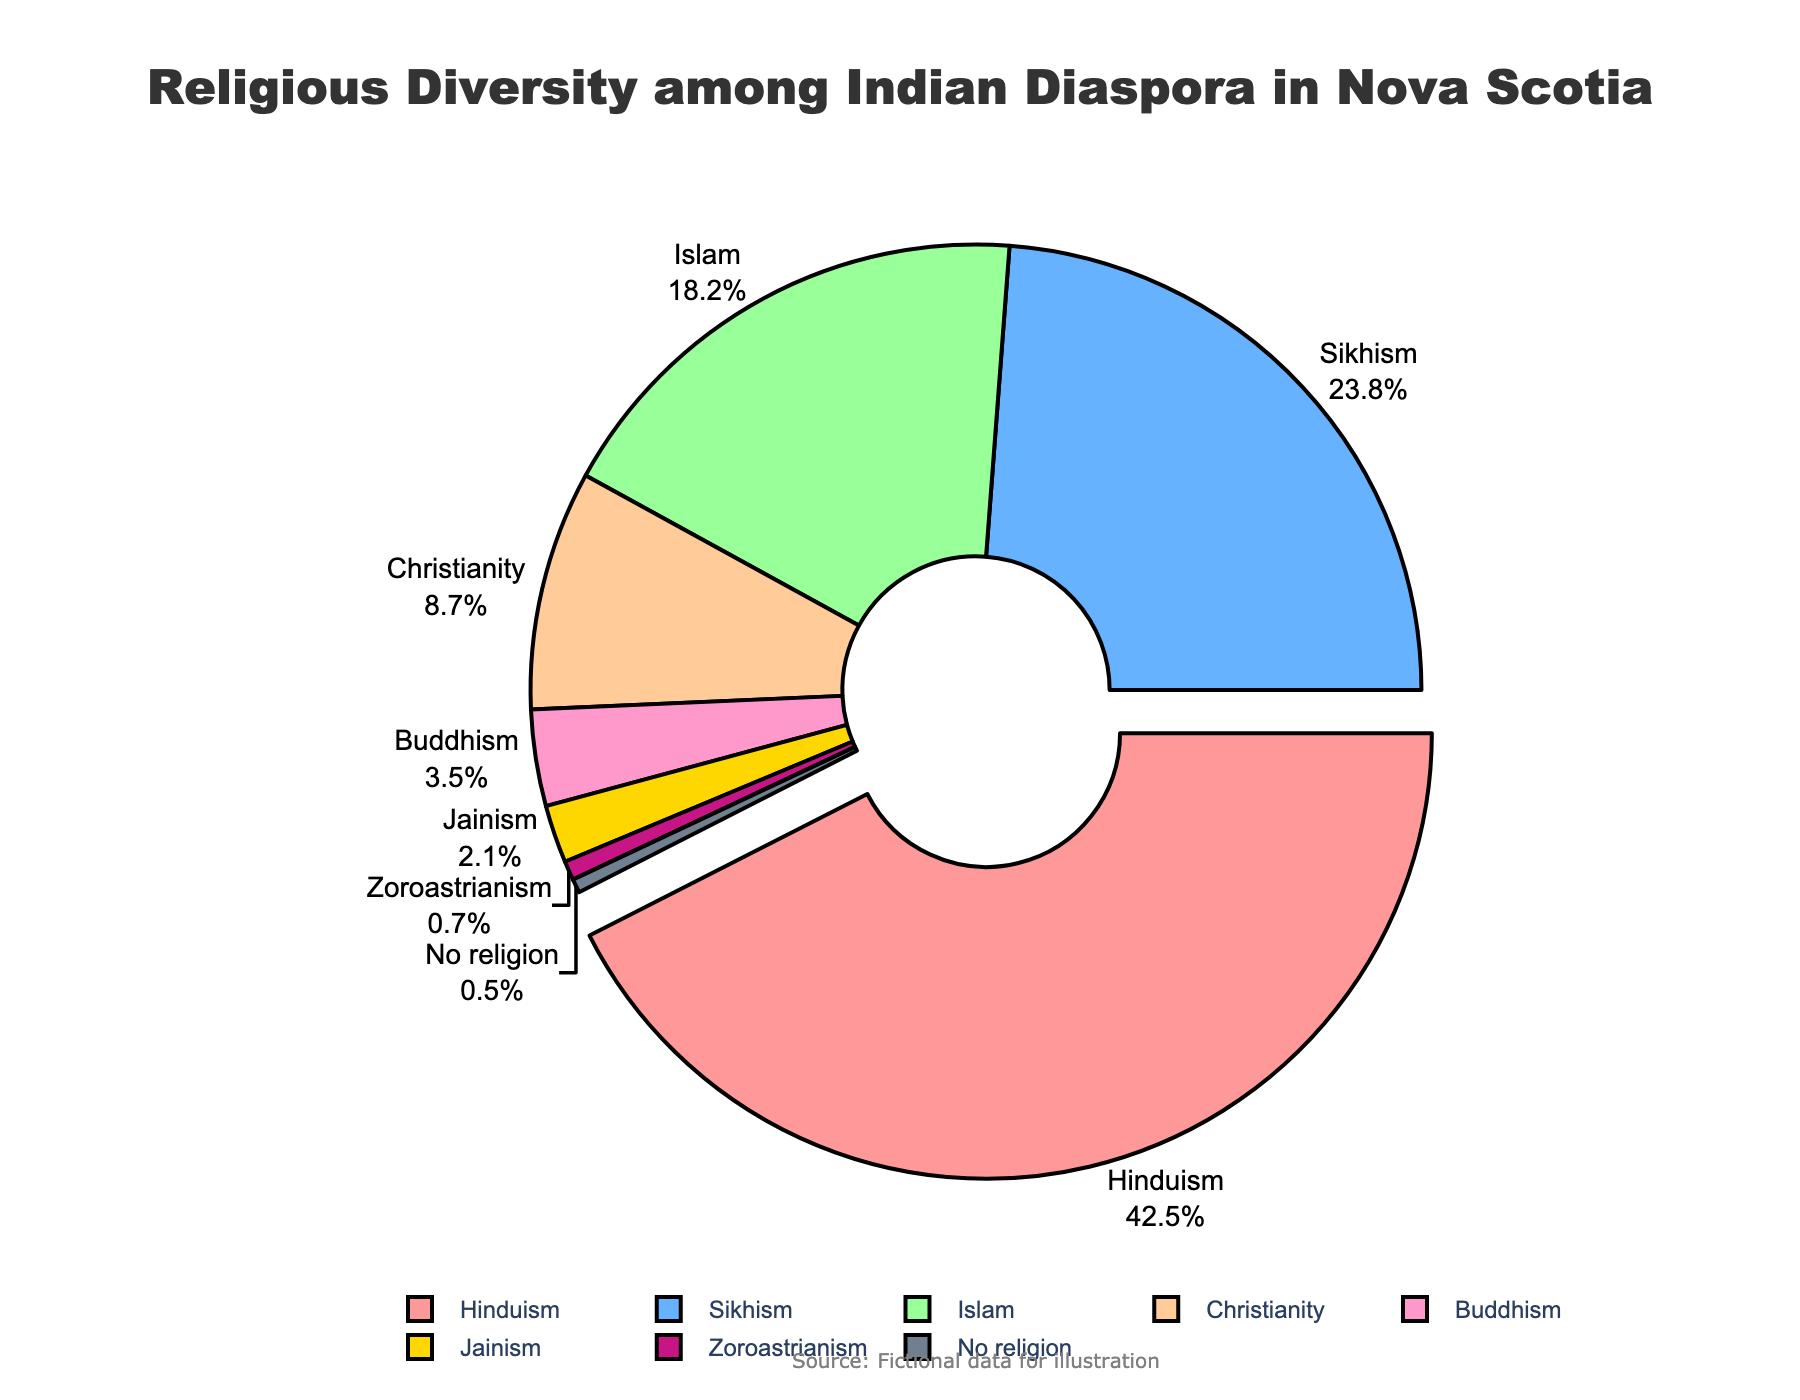Which religion has the highest percentage among the Indian diaspora in Nova Scotia? By looking at the pie chart, observe which segment is pulled out and has the highest value indicated in the percentage label.
Answer: Hinduism What is the total percentage of people following Islam and Christianity? Sum the percentages of Islam (18.2%) and Christianity (8.7%). 18.2 + 8.7 = 26.9
Answer: 26.9% How does the percentage of Sikhs compare to the percentage of Buddhists? Compare the respective percentages of Sikhs (23.8%) and Buddhists (3.5%). 23.8 is greater than 3.5.
Answer: Sikhs have a higher percentage What's the combined percentage of people following Jainism and Zoroastrianism? Sum the percentages of Jainism (2.1%) and Zoroastrianism (0.7%). 2.1 + 0.7 = 2.8
Answer: 2.8% Which religions have percentages below 5%? Identify all segments with percentages indicated below 5%. These are Buddhism, Jainism, Zoroastrianism, and No religion.
Answer: Buddhism, Jainism, Zoroastrianism, No religion What is the percentage difference between Hindus and Sikhs? Subtract the percentage of Sikhs (23.8%) from the percentage of Hindus (42.5%). 42.5 - 23.8 = 18.7
Answer: 18.7% Among the religions listed, which has the smallest representation and what is its percentage? Look for the religion with the smallest slice and observe its labeled percentage.
Answer: No religion, 0.5% What is the average percentage of people following Buddhism, Jainism, and Zoroastrianism? Sum the percentages of Buddhism (3.5%), Jainism (2.1%), and Zoroastrianism (0.7%) and then divide by 3. (3.5 + 2.1 + 0.7) / 3 = 2.1
Answer: 2.1% Which religions have a percentage greater than 20%? Identify the segments that have percentage values above 20%. These are Hinduism (42.5%) and Sikhism (23.8%).
Answer: Hinduism, Sikhism 